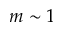Convert formula to latex. <formula><loc_0><loc_0><loc_500><loc_500>m \sim 1</formula> 